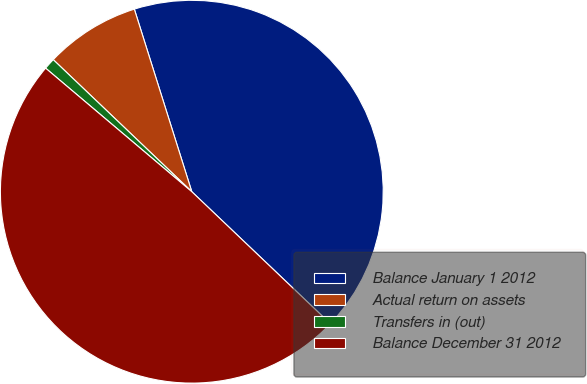Convert chart to OTSL. <chart><loc_0><loc_0><loc_500><loc_500><pie_chart><fcel>Balance January 1 2012<fcel>Actual return on assets<fcel>Transfers in (out)<fcel>Balance December 31 2012<nl><fcel>41.97%<fcel>8.03%<fcel>0.95%<fcel>49.05%<nl></chart> 